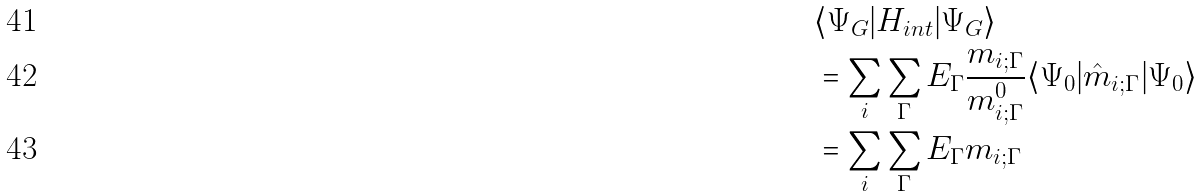<formula> <loc_0><loc_0><loc_500><loc_500>& \langle \Psi _ { G } | H _ { i n t } | \Psi _ { G } \rangle \\ & = \sum _ { i } \sum _ { \Gamma } E _ { \Gamma } \frac { m _ { i ; \Gamma } } { m _ { i ; \Gamma } ^ { 0 } } \langle \Psi _ { 0 } | \hat { m } _ { i ; \Gamma } | \Psi _ { 0 } \rangle \\ & = \sum _ { i } \sum _ { \Gamma } E _ { \Gamma } m _ { i ; \Gamma }</formula> 